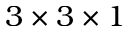Convert formula to latex. <formula><loc_0><loc_0><loc_500><loc_500>3 \times 3 \times 1</formula> 